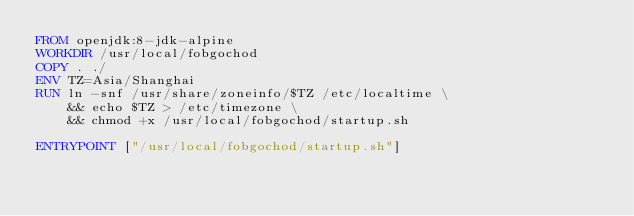<code> <loc_0><loc_0><loc_500><loc_500><_Dockerfile_>FROM openjdk:8-jdk-alpine
WORKDIR /usr/local/fobgochod
COPY . ./
ENV TZ=Asia/Shanghai
RUN ln -snf /usr/share/zoneinfo/$TZ /etc/localtime \
    && echo $TZ > /etc/timezone \
    && chmod +x /usr/local/fobgochod/startup.sh

ENTRYPOINT ["/usr/local/fobgochod/startup.sh"]
</code> 